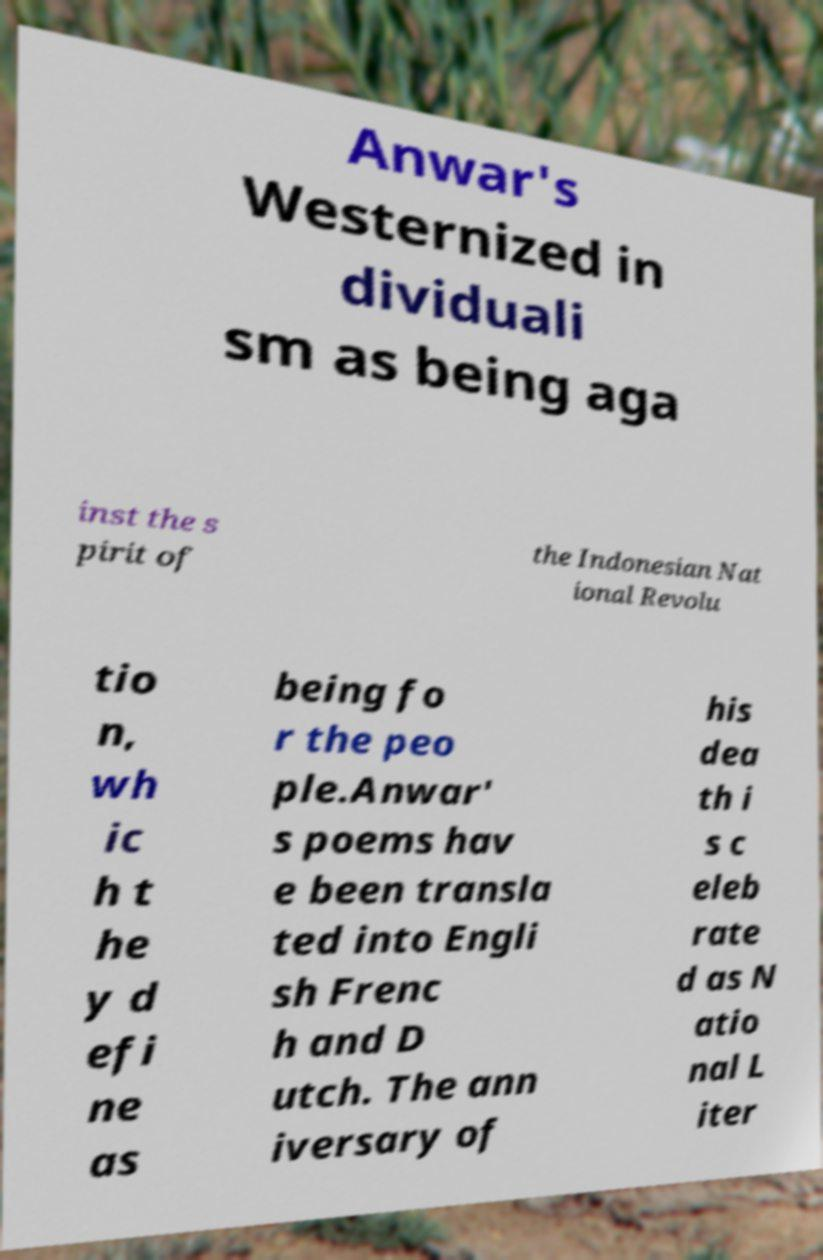For documentation purposes, I need the text within this image transcribed. Could you provide that? Anwar's Westernized in dividuali sm as being aga inst the s pirit of the Indonesian Nat ional Revolu tio n, wh ic h t he y d efi ne as being fo r the peo ple.Anwar' s poems hav e been transla ted into Engli sh Frenc h and D utch. The ann iversary of his dea th i s c eleb rate d as N atio nal L iter 